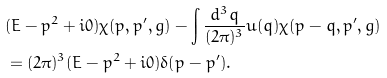<formula> <loc_0><loc_0><loc_500><loc_500>& ( E - { p } ^ { 2 } + i 0 ) \chi ( { p } , { p } ^ { \prime } , g ) - \int \frac { d ^ { 3 } { q } } { ( 2 \pi ) ^ { 3 } } u ( { q } ) \chi ( { p } - { q } , { p } ^ { \prime } , g ) \\ & = ( 2 \pi ) ^ { 3 } ( E - { p } ^ { 2 } + i 0 ) \delta ( { p } - { p } ^ { \prime } ) .</formula> 